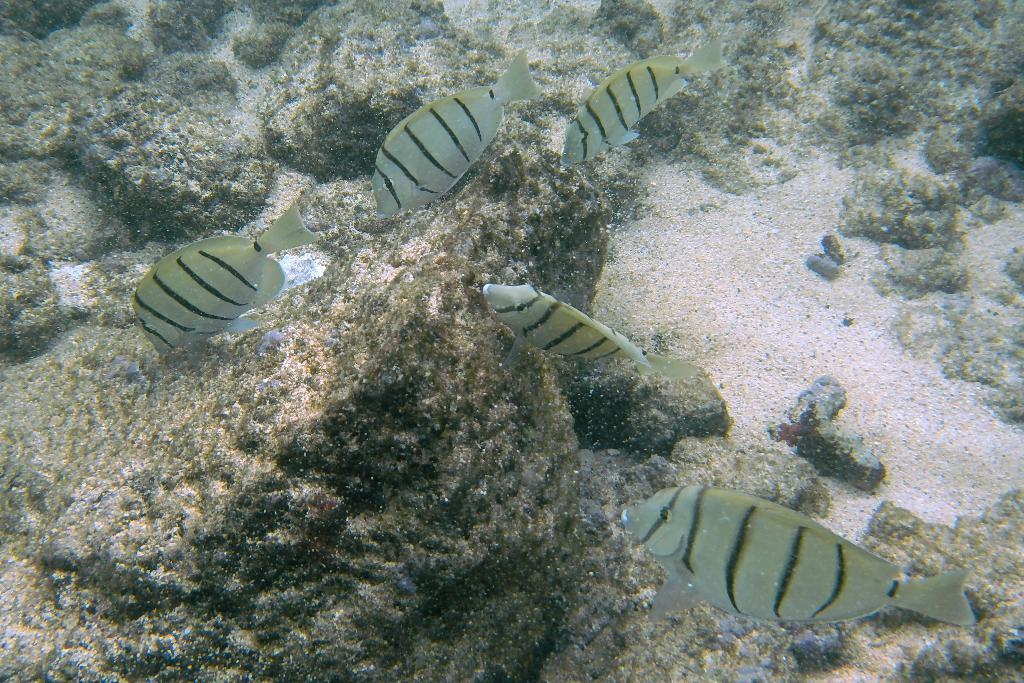How would you summarize this image in a sentence or two? In this image we can see fishes are floating in the water and we can see rocks and sand. 